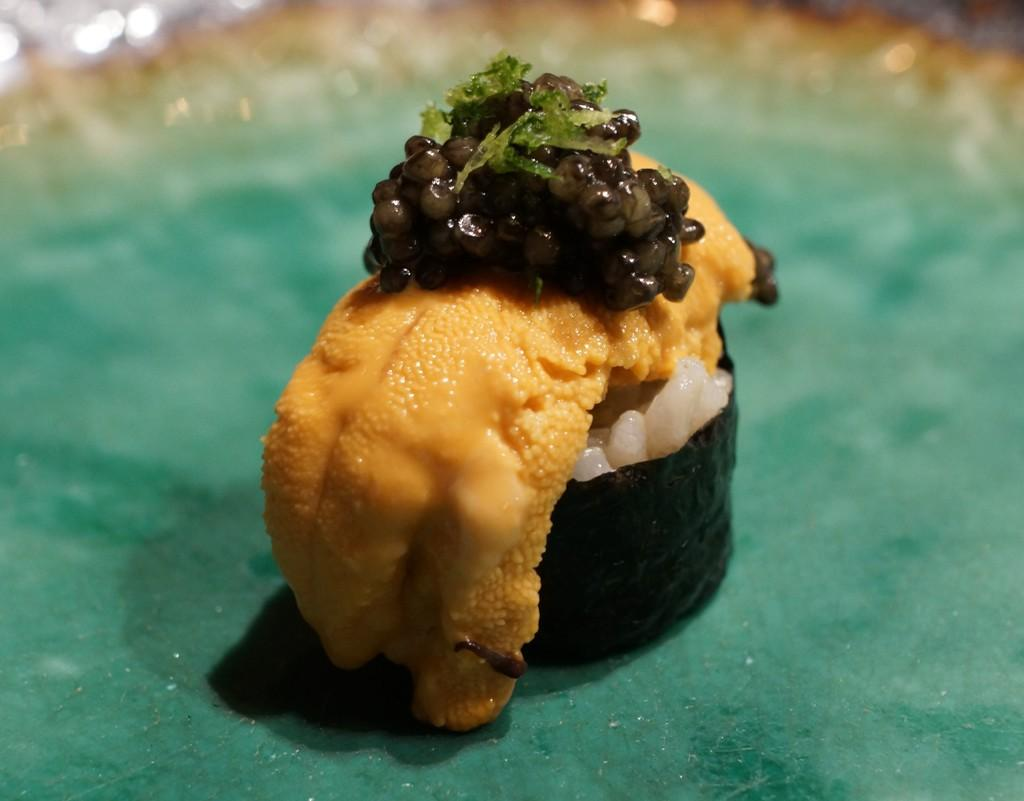What type of food is visible in the image? There is sushi in the image. What is the color of the surface on which the sushi is placed? The sushi is placed on a green surface. What theory is the writer discussing in the image? There is no writer or discussion of a theory present in the image; it only features sushi on a green surface. 